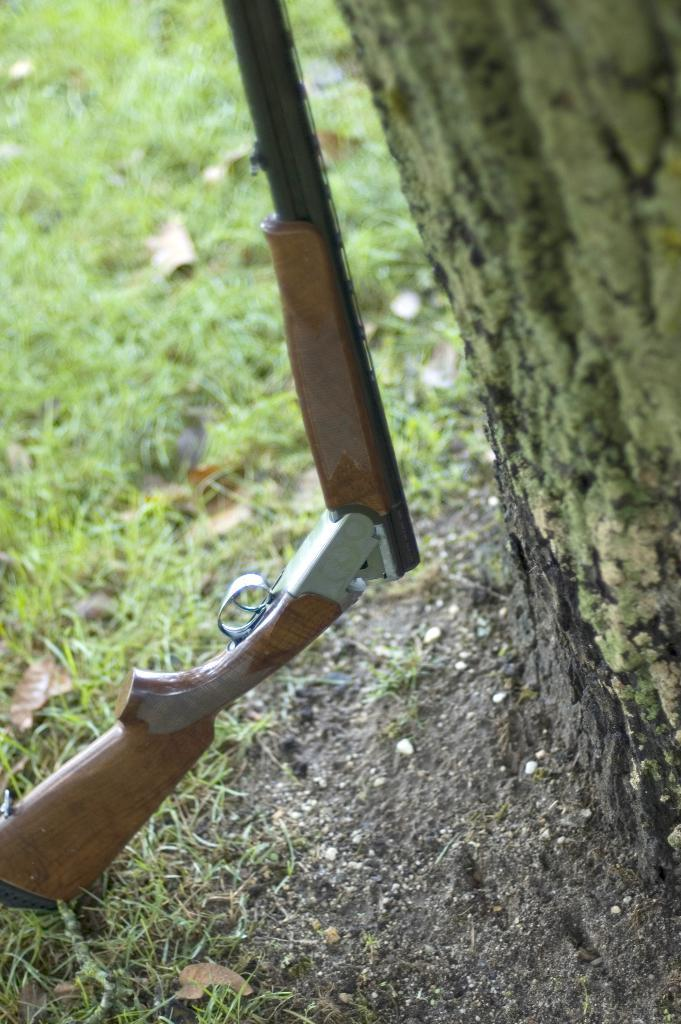What object is placed on the grass in the image? There is a gun on the grass in the image. What other object can be seen in the image? There is a trunk in the image. How is the distribution of the gun and trunk being tested in the image? There is no indication in the image that the distribution of the gun and trunk is being tested. 